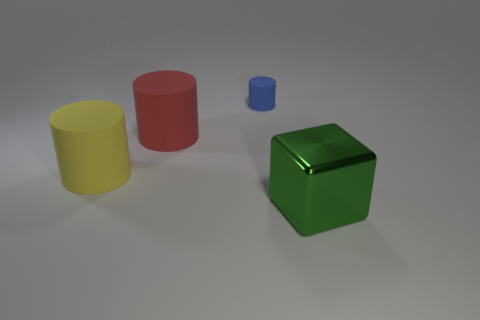Add 1 yellow cylinders. How many objects exist? 5 Subtract all blue cylinders. How many cylinders are left? 2 Add 3 big red shiny cylinders. How many big red shiny cylinders exist? 3 Subtract 0 blue blocks. How many objects are left? 4 Subtract all blocks. How many objects are left? 3 Subtract 2 cylinders. How many cylinders are left? 1 Subtract all blue cubes. Subtract all yellow balls. How many cubes are left? 1 Subtract all gray cubes. How many blue cylinders are left? 1 Subtract all big red objects. Subtract all green cubes. How many objects are left? 2 Add 1 green metallic things. How many green metallic things are left? 2 